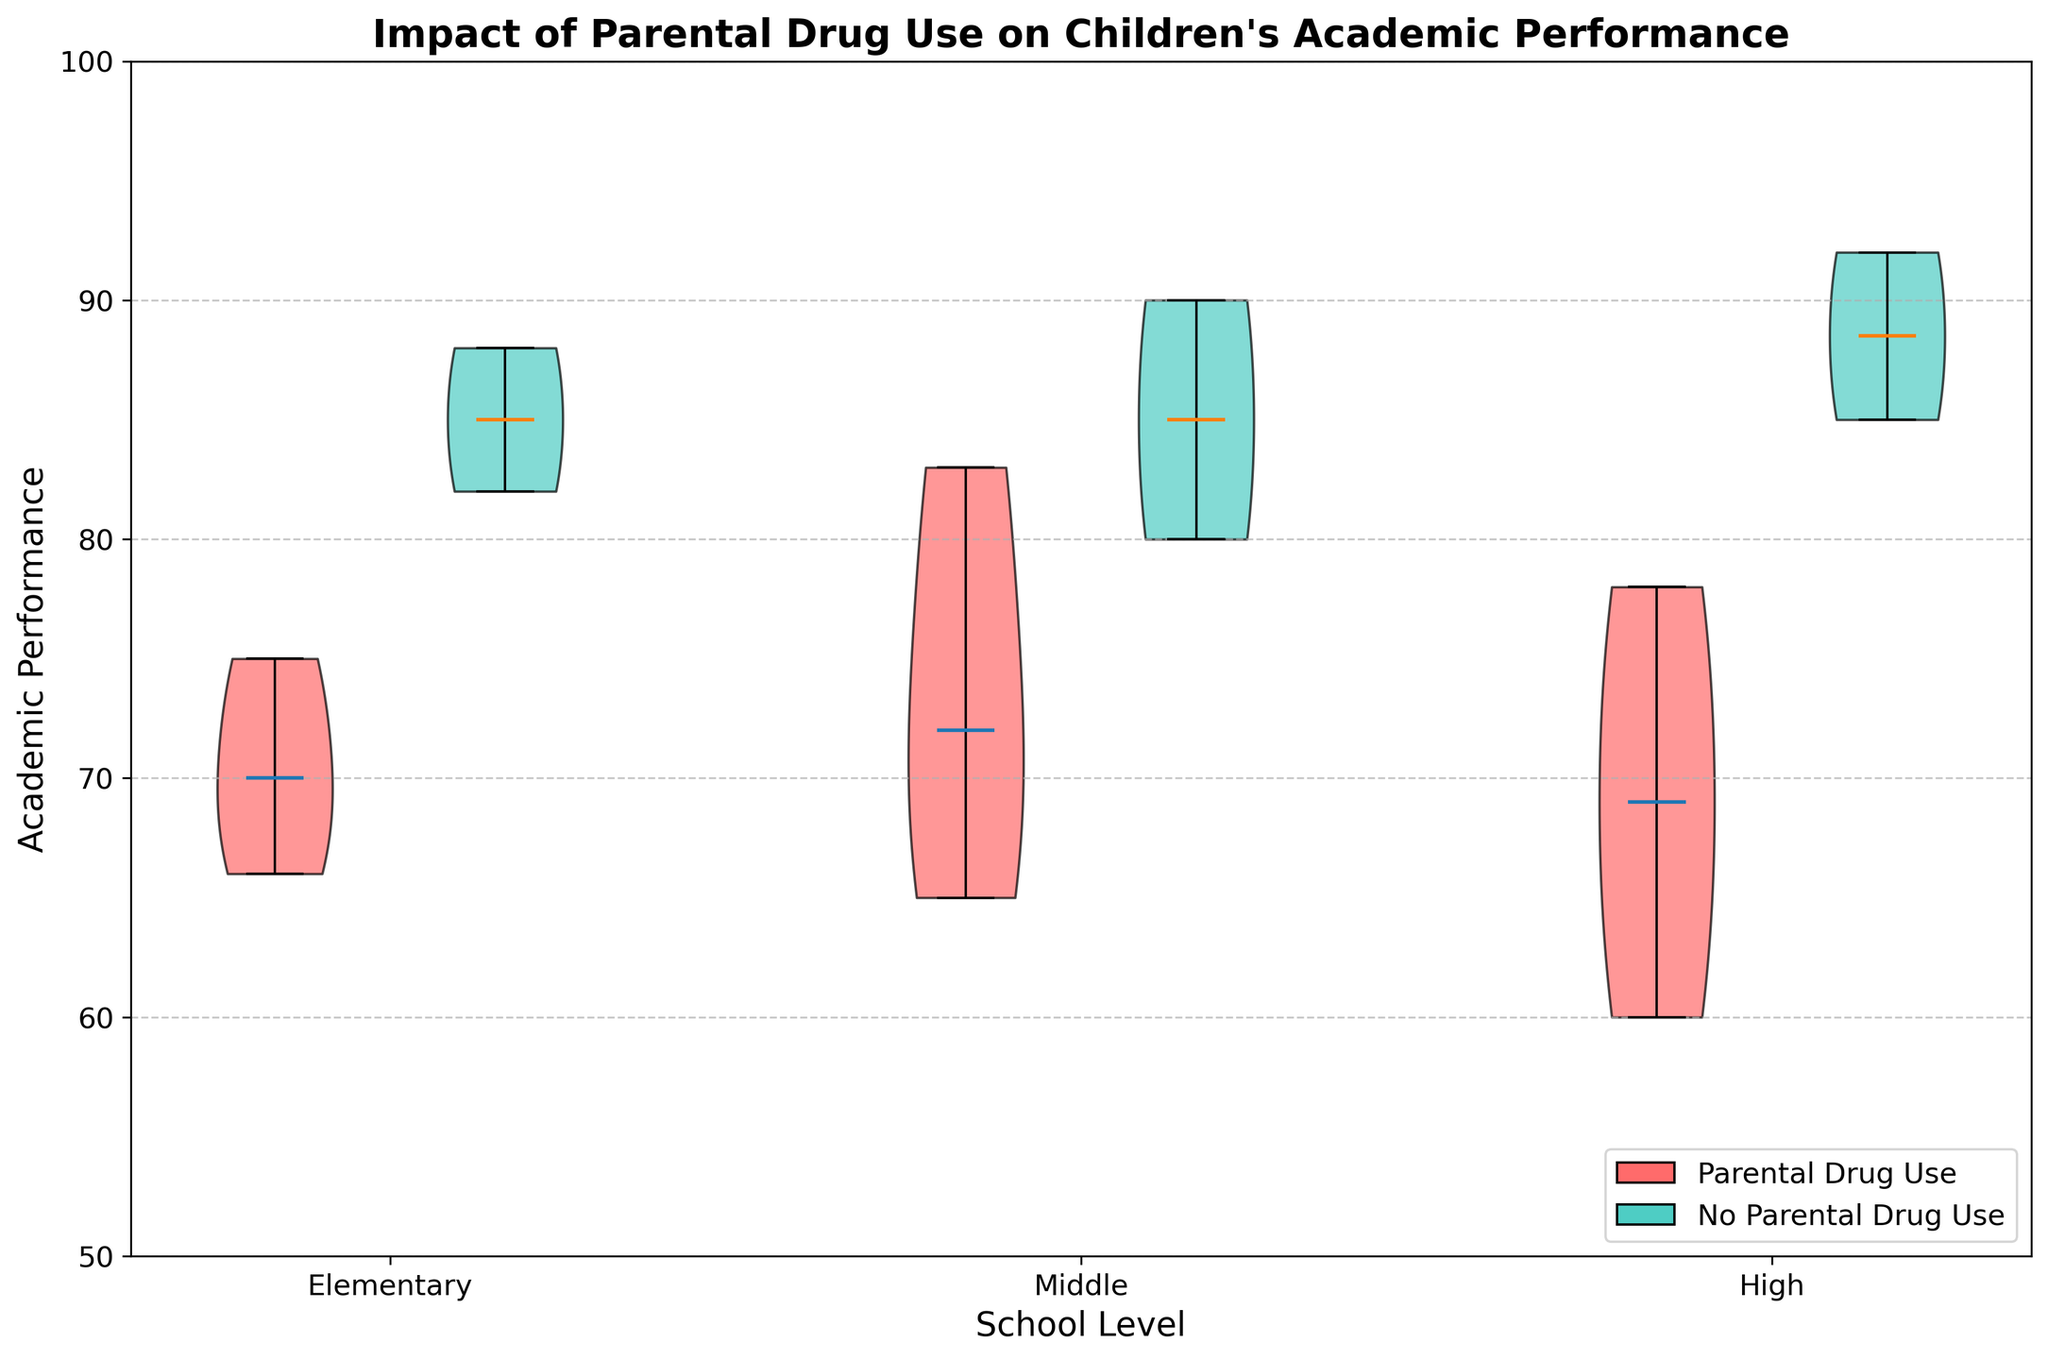What are the colors used to represent parental drug use and no parental drug use? The figure uses two colors to differentiate between the groups. The red color represents "Parental Drug Use," and the teal color represents "No Parental Drug Use."
Answer: Red for Parental Drug Use, Teal for No Parental Drug Use What's the median academic performance for elementary students with parental drug use? The violin plot for elementary students with parental drug use (red color) shows a horizontal line indicating the median. This line is located at 70.
Answer: 70 How do the median academic performances compare between middle school students with and without parental drug use? In the violin plot, the black horizontal lines inside the violins indicate the medians. For middle school students, the violin representing parental drug use (red) has a median around 72, while the one without parental drug use (teal) has a median around 85.
Answer: 72 for parental drug use, 85 for no parental drug use Which school level shows the highest median academic performance among students with no parental drug use? Observing the black horizontal median lines within the teal violin plots, the high school level shows the highest median academic performance, which is around 92.
Answer: High school Is the distribution of academic performance wider for elementary students with or without parental drug use? The width of the violin plot indicates distribution spread. For elementary students, the plot representing parental drug use (red) is notably wider than the one for no parental drug use (teal), indicating a wider distribution.
Answer: With parental drug use What's the general trend of median academic performance from elementary to high school for students with parental drug use? Look at the black horizontal median lines within the red violin plots for each school level. The median academic performance appears to increase from elementary (70) to middle (72) to high school (69).
Answer: Increases slightly, then decreases Compare the variability in academic performances among high school students with and without parental drug use. The width and shape of the violin plots represent the variability. High school students with parental drug use (red) have a wider plot than those without parental drug use (teal), suggesting greater variability in academic performances.
Answer: Greater variability with parental drug use What is the range of academic performance for middle school students with parental drug use? The lower and upper edges of the violin plot indicate the range. For middle school students with parental drug use (red), the range appears to be from approximately 65 to 83.
Answer: 65 to 83 